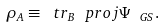Convert formula to latex. <formula><loc_0><loc_0><loc_500><loc_500>\rho _ { A } \equiv \ t r _ { B } \ p r o j { \Psi _ { \ G S } } .</formula> 